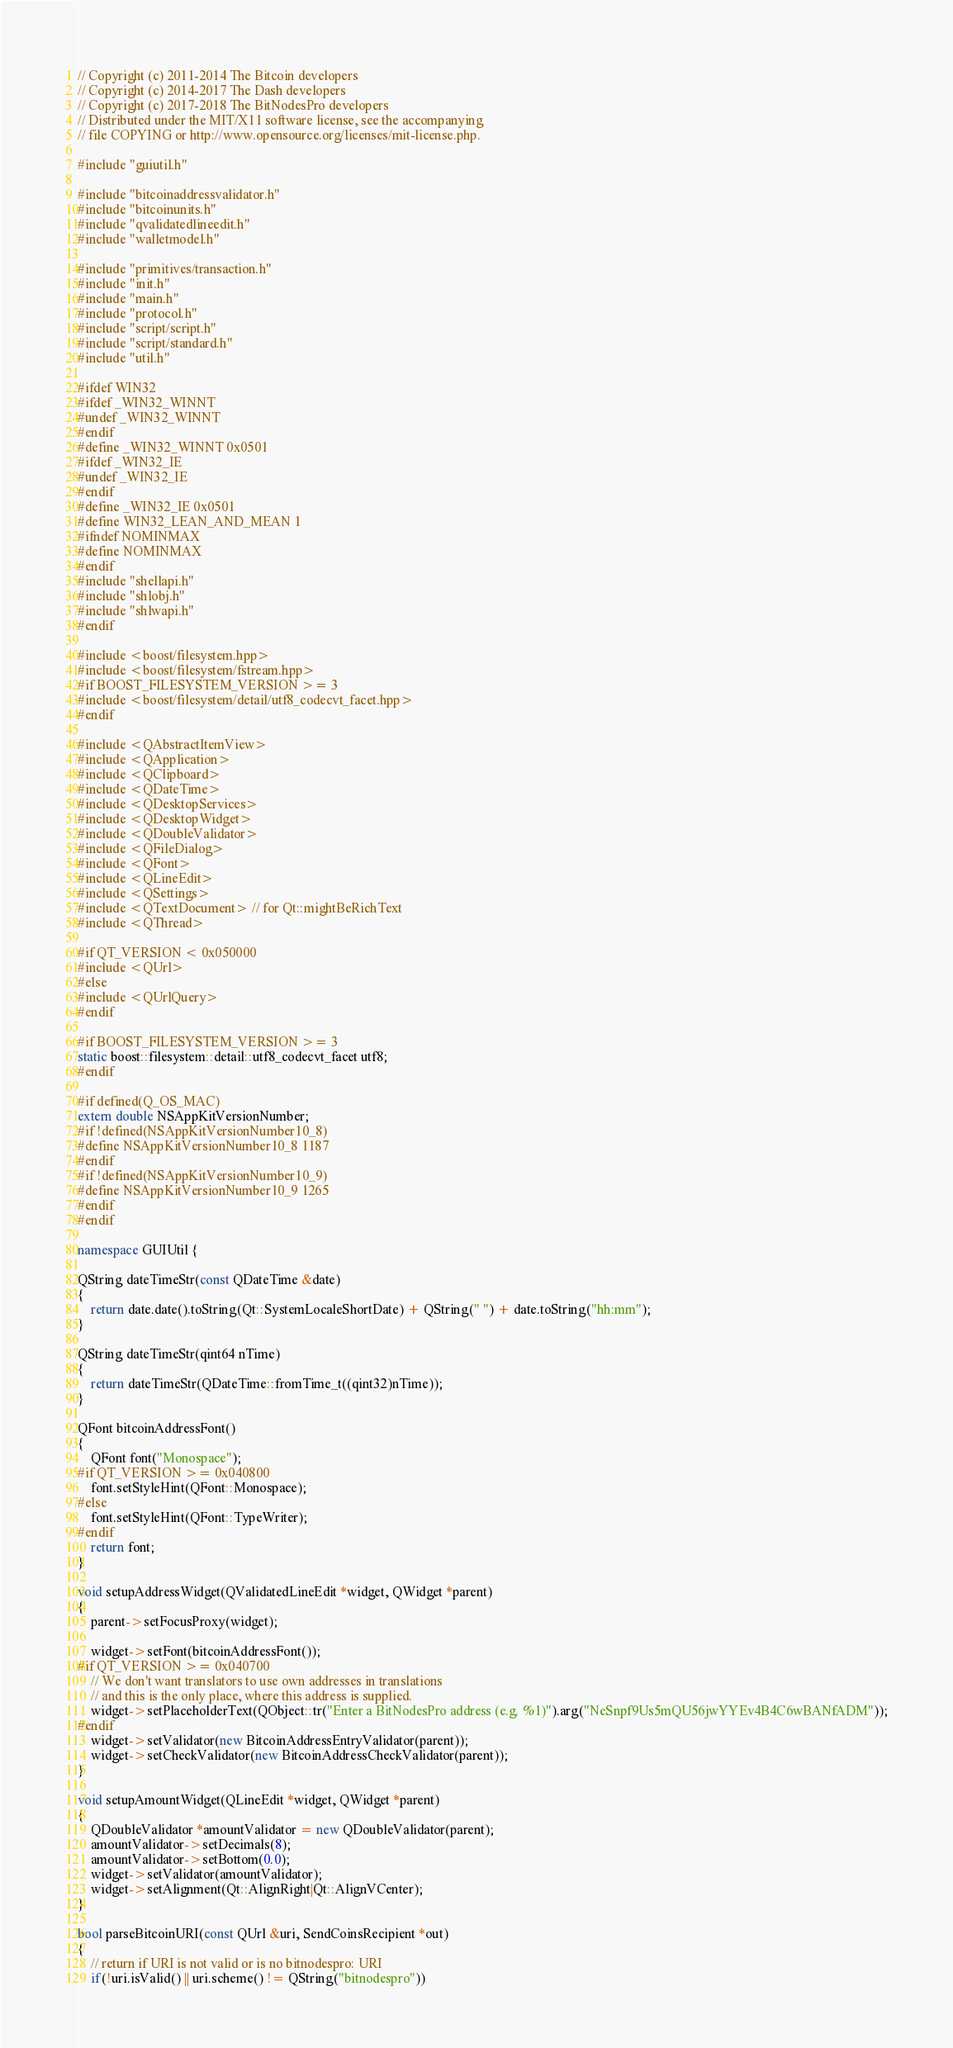<code> <loc_0><loc_0><loc_500><loc_500><_C++_>// Copyright (c) 2011-2014 The Bitcoin developers
// Copyright (c) 2014-2017 The Dash developers
// Copyright (c) 2017-2018 The BitNodesPro developers
// Distributed under the MIT/X11 software license, see the accompanying
// file COPYING or http://www.opensource.org/licenses/mit-license.php.

#include "guiutil.h"

#include "bitcoinaddressvalidator.h"
#include "bitcoinunits.h"
#include "qvalidatedlineedit.h"
#include "walletmodel.h"

#include "primitives/transaction.h"
#include "init.h"
#include "main.h"
#include "protocol.h"
#include "script/script.h"
#include "script/standard.h"
#include "util.h"

#ifdef WIN32
#ifdef _WIN32_WINNT
#undef _WIN32_WINNT
#endif
#define _WIN32_WINNT 0x0501
#ifdef _WIN32_IE
#undef _WIN32_IE
#endif
#define _WIN32_IE 0x0501
#define WIN32_LEAN_AND_MEAN 1
#ifndef NOMINMAX
#define NOMINMAX
#endif
#include "shellapi.h"
#include "shlobj.h"
#include "shlwapi.h"
#endif

#include <boost/filesystem.hpp>
#include <boost/filesystem/fstream.hpp>
#if BOOST_FILESYSTEM_VERSION >= 3
#include <boost/filesystem/detail/utf8_codecvt_facet.hpp>
#endif

#include <QAbstractItemView>
#include <QApplication>
#include <QClipboard>
#include <QDateTime>
#include <QDesktopServices>
#include <QDesktopWidget>
#include <QDoubleValidator>
#include <QFileDialog>
#include <QFont>
#include <QLineEdit>
#include <QSettings>
#include <QTextDocument> // for Qt::mightBeRichText
#include <QThread>

#if QT_VERSION < 0x050000
#include <QUrl>
#else
#include <QUrlQuery>
#endif

#if BOOST_FILESYSTEM_VERSION >= 3
static boost::filesystem::detail::utf8_codecvt_facet utf8;
#endif

#if defined(Q_OS_MAC)
extern double NSAppKitVersionNumber;
#if !defined(NSAppKitVersionNumber10_8)
#define NSAppKitVersionNumber10_8 1187
#endif
#if !defined(NSAppKitVersionNumber10_9)
#define NSAppKitVersionNumber10_9 1265
#endif
#endif

namespace GUIUtil {

QString dateTimeStr(const QDateTime &date)
{
    return date.date().toString(Qt::SystemLocaleShortDate) + QString(" ") + date.toString("hh:mm");
}

QString dateTimeStr(qint64 nTime)
{
    return dateTimeStr(QDateTime::fromTime_t((qint32)nTime));
}

QFont bitcoinAddressFont()
{
    QFont font("Monospace");
#if QT_VERSION >= 0x040800
    font.setStyleHint(QFont::Monospace);
#else
    font.setStyleHint(QFont::TypeWriter);
#endif
    return font;
}

void setupAddressWidget(QValidatedLineEdit *widget, QWidget *parent)
{
    parent->setFocusProxy(widget);

    widget->setFont(bitcoinAddressFont());
#if QT_VERSION >= 0x040700
    // We don't want translators to use own addresses in translations
    // and this is the only place, where this address is supplied.
    widget->setPlaceholderText(QObject::tr("Enter a BitNodesPro address (e.g. %1)").arg("NeSnpf9Us5mQU56jwYYEv4B4C6wBANfADM"));
#endif
    widget->setValidator(new BitcoinAddressEntryValidator(parent));
    widget->setCheckValidator(new BitcoinAddressCheckValidator(parent));
}

void setupAmountWidget(QLineEdit *widget, QWidget *parent)
{
    QDoubleValidator *amountValidator = new QDoubleValidator(parent);
    amountValidator->setDecimals(8);
    amountValidator->setBottom(0.0);
    widget->setValidator(amountValidator);
    widget->setAlignment(Qt::AlignRight|Qt::AlignVCenter);
}

bool parseBitcoinURI(const QUrl &uri, SendCoinsRecipient *out)
{
    // return if URI is not valid or is no bitnodespro: URI
    if(!uri.isValid() || uri.scheme() != QString("bitnodespro"))</code> 